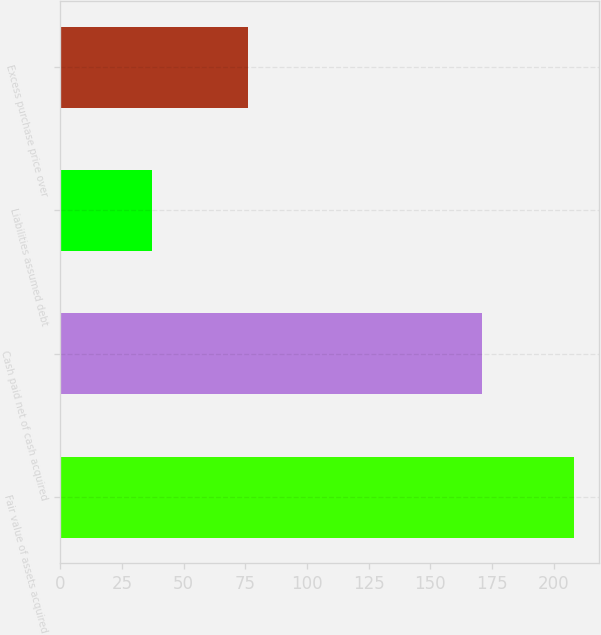Convert chart. <chart><loc_0><loc_0><loc_500><loc_500><bar_chart><fcel>Fair value of assets acquired<fcel>Cash paid net of cash acquired<fcel>Liabilities assumed debt<fcel>Excess purchase price over<nl><fcel>208<fcel>171<fcel>37<fcel>76<nl></chart> 